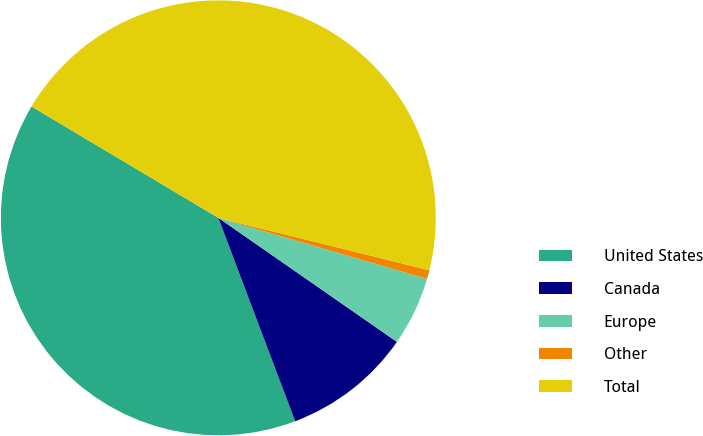Convert chart to OTSL. <chart><loc_0><loc_0><loc_500><loc_500><pie_chart><fcel>United States<fcel>Canada<fcel>Europe<fcel>Other<fcel>Total<nl><fcel>39.3%<fcel>9.59%<fcel>5.13%<fcel>0.66%<fcel>45.32%<nl></chart> 